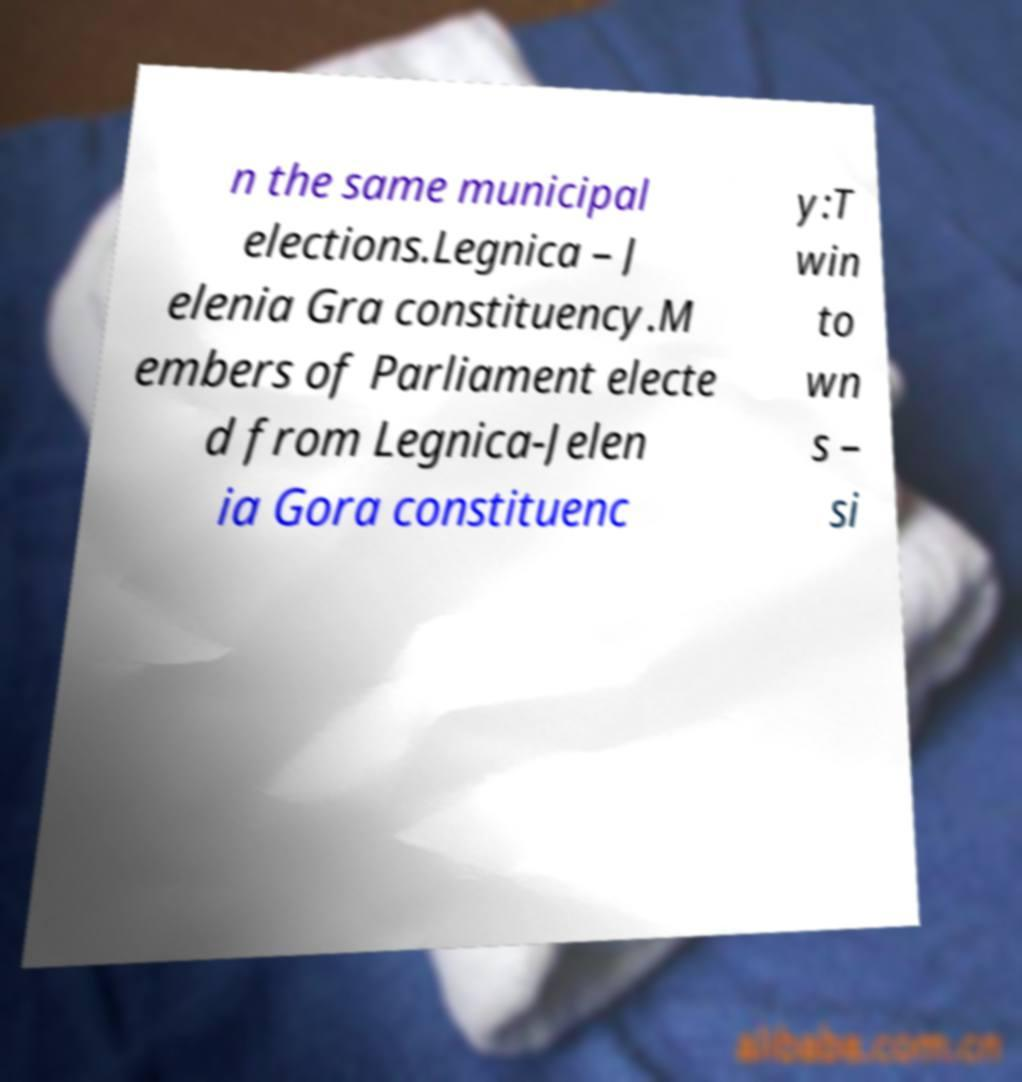What messages or text are displayed in this image? I need them in a readable, typed format. n the same municipal elections.Legnica – J elenia Gra constituency.M embers of Parliament electe d from Legnica-Jelen ia Gora constituenc y:T win to wn s – si 